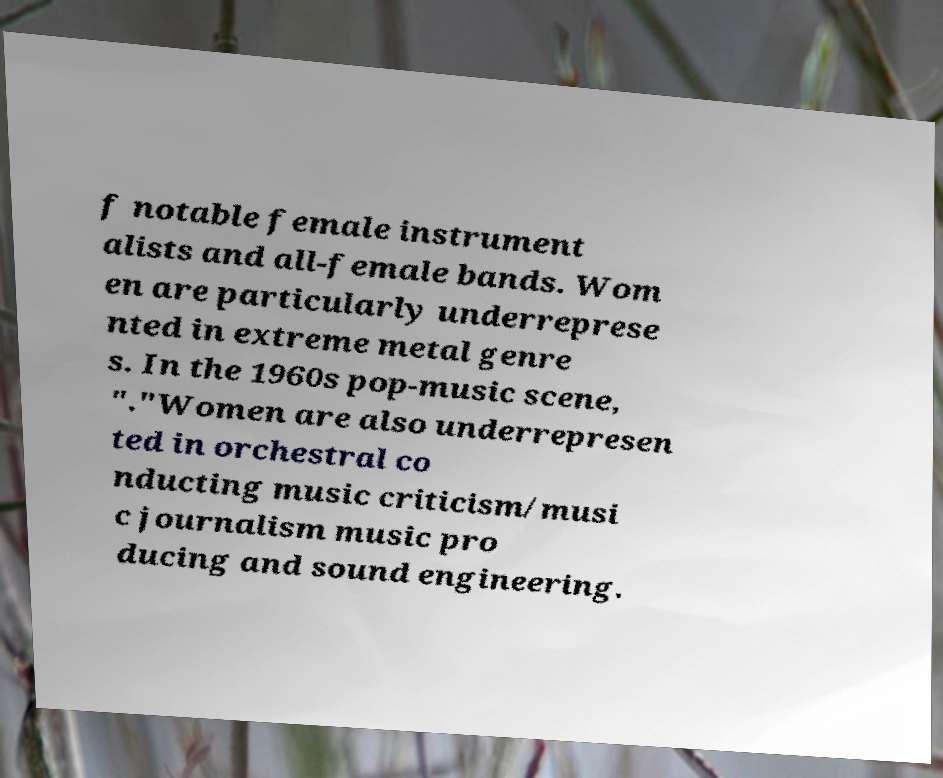There's text embedded in this image that I need extracted. Can you transcribe it verbatim? f notable female instrument alists and all-female bands. Wom en are particularly underreprese nted in extreme metal genre s. In the 1960s pop-music scene, "."Women are also underrepresen ted in orchestral co nducting music criticism/musi c journalism music pro ducing and sound engineering. 